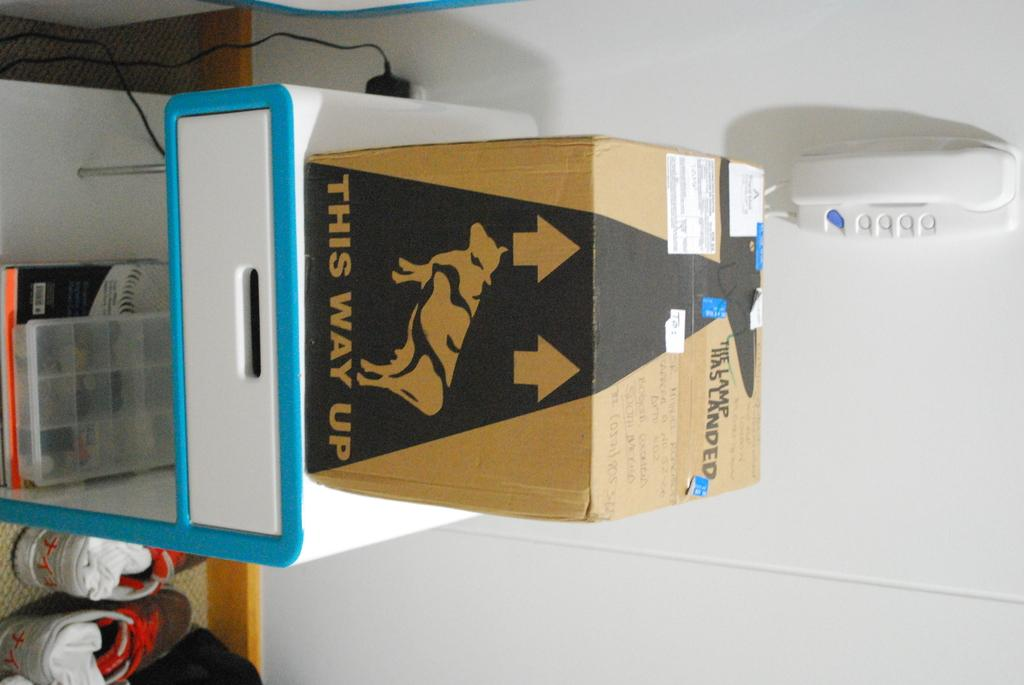<image>
Describe the image concisely. A box on a stand, the box reads This way up on one side 